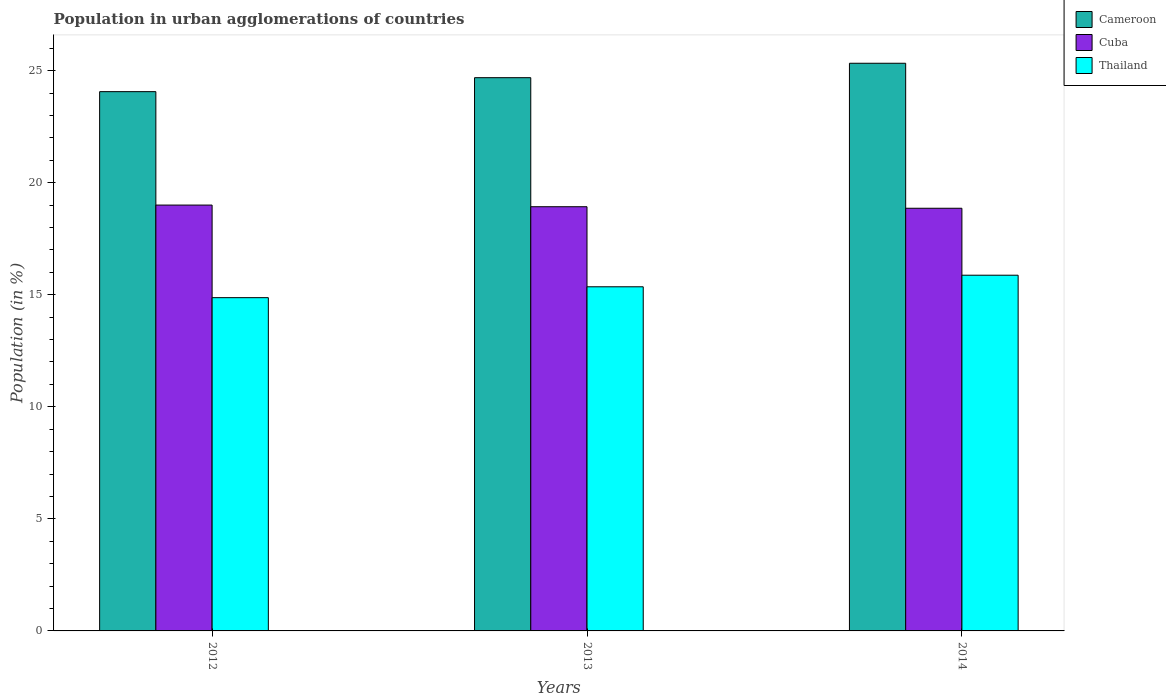How many different coloured bars are there?
Provide a succinct answer. 3. Are the number of bars per tick equal to the number of legend labels?
Keep it short and to the point. Yes. Are the number of bars on each tick of the X-axis equal?
Give a very brief answer. Yes. How many bars are there on the 3rd tick from the left?
Give a very brief answer. 3. How many bars are there on the 1st tick from the right?
Offer a very short reply. 3. In how many cases, is the number of bars for a given year not equal to the number of legend labels?
Your answer should be compact. 0. What is the percentage of population in urban agglomerations in Thailand in 2013?
Offer a very short reply. 15.36. Across all years, what is the maximum percentage of population in urban agglomerations in Thailand?
Keep it short and to the point. 15.87. Across all years, what is the minimum percentage of population in urban agglomerations in Cameroon?
Give a very brief answer. 24.06. In which year was the percentage of population in urban agglomerations in Thailand minimum?
Offer a terse response. 2012. What is the total percentage of population in urban agglomerations in Cameroon in the graph?
Your response must be concise. 74.08. What is the difference between the percentage of population in urban agglomerations in Cuba in 2013 and that in 2014?
Your answer should be compact. 0.07. What is the difference between the percentage of population in urban agglomerations in Cuba in 2012 and the percentage of population in urban agglomerations in Cameroon in 2013?
Offer a terse response. -5.68. What is the average percentage of population in urban agglomerations in Thailand per year?
Ensure brevity in your answer.  15.37. In the year 2012, what is the difference between the percentage of population in urban agglomerations in Cameroon and percentage of population in urban agglomerations in Thailand?
Make the answer very short. 9.19. In how many years, is the percentage of population in urban agglomerations in Cuba greater than 18 %?
Give a very brief answer. 3. What is the ratio of the percentage of population in urban agglomerations in Thailand in 2012 to that in 2014?
Keep it short and to the point. 0.94. Is the difference between the percentage of population in urban agglomerations in Cameroon in 2012 and 2014 greater than the difference between the percentage of population in urban agglomerations in Thailand in 2012 and 2014?
Offer a terse response. No. What is the difference between the highest and the second highest percentage of population in urban agglomerations in Thailand?
Offer a terse response. 0.52. What is the difference between the highest and the lowest percentage of population in urban agglomerations in Thailand?
Give a very brief answer. 1. What does the 2nd bar from the left in 2013 represents?
Your answer should be compact. Cuba. What does the 3rd bar from the right in 2012 represents?
Provide a short and direct response. Cameroon. Is it the case that in every year, the sum of the percentage of population in urban agglomerations in Thailand and percentage of population in urban agglomerations in Cuba is greater than the percentage of population in urban agglomerations in Cameroon?
Keep it short and to the point. Yes. How many bars are there?
Give a very brief answer. 9. How many years are there in the graph?
Offer a terse response. 3. What is the difference between two consecutive major ticks on the Y-axis?
Keep it short and to the point. 5. Are the values on the major ticks of Y-axis written in scientific E-notation?
Your response must be concise. No. Where does the legend appear in the graph?
Provide a short and direct response. Top right. What is the title of the graph?
Your response must be concise. Population in urban agglomerations of countries. Does "Gabon" appear as one of the legend labels in the graph?
Ensure brevity in your answer.  No. What is the label or title of the X-axis?
Your answer should be compact. Years. What is the Population (in %) of Cameroon in 2012?
Your answer should be very brief. 24.06. What is the Population (in %) in Cuba in 2012?
Your answer should be very brief. 19. What is the Population (in %) in Thailand in 2012?
Provide a succinct answer. 14.87. What is the Population (in %) of Cameroon in 2013?
Keep it short and to the point. 24.69. What is the Population (in %) of Cuba in 2013?
Make the answer very short. 18.93. What is the Population (in %) of Thailand in 2013?
Offer a very short reply. 15.36. What is the Population (in %) of Cameroon in 2014?
Offer a terse response. 25.33. What is the Population (in %) of Cuba in 2014?
Give a very brief answer. 18.86. What is the Population (in %) in Thailand in 2014?
Keep it short and to the point. 15.87. Across all years, what is the maximum Population (in %) of Cameroon?
Your answer should be very brief. 25.33. Across all years, what is the maximum Population (in %) in Cuba?
Ensure brevity in your answer.  19. Across all years, what is the maximum Population (in %) in Thailand?
Your answer should be very brief. 15.87. Across all years, what is the minimum Population (in %) of Cameroon?
Ensure brevity in your answer.  24.06. Across all years, what is the minimum Population (in %) of Cuba?
Your response must be concise. 18.86. Across all years, what is the minimum Population (in %) in Thailand?
Keep it short and to the point. 14.87. What is the total Population (in %) in Cameroon in the graph?
Offer a terse response. 74.08. What is the total Population (in %) in Cuba in the graph?
Offer a terse response. 56.79. What is the total Population (in %) of Thailand in the graph?
Make the answer very short. 46.1. What is the difference between the Population (in %) of Cameroon in 2012 and that in 2013?
Ensure brevity in your answer.  -0.62. What is the difference between the Population (in %) of Cuba in 2012 and that in 2013?
Offer a very short reply. 0.07. What is the difference between the Population (in %) in Thailand in 2012 and that in 2013?
Offer a terse response. -0.49. What is the difference between the Population (in %) of Cameroon in 2012 and that in 2014?
Your answer should be very brief. -1.27. What is the difference between the Population (in %) in Cuba in 2012 and that in 2014?
Your response must be concise. 0.14. What is the difference between the Population (in %) in Thailand in 2012 and that in 2014?
Your answer should be very brief. -1. What is the difference between the Population (in %) of Cameroon in 2013 and that in 2014?
Provide a short and direct response. -0.64. What is the difference between the Population (in %) in Cuba in 2013 and that in 2014?
Ensure brevity in your answer.  0.07. What is the difference between the Population (in %) in Thailand in 2013 and that in 2014?
Offer a very short reply. -0.52. What is the difference between the Population (in %) of Cameroon in 2012 and the Population (in %) of Cuba in 2013?
Provide a succinct answer. 5.14. What is the difference between the Population (in %) of Cameroon in 2012 and the Population (in %) of Thailand in 2013?
Keep it short and to the point. 8.71. What is the difference between the Population (in %) in Cuba in 2012 and the Population (in %) in Thailand in 2013?
Give a very brief answer. 3.65. What is the difference between the Population (in %) of Cameroon in 2012 and the Population (in %) of Cuba in 2014?
Give a very brief answer. 5.2. What is the difference between the Population (in %) of Cameroon in 2012 and the Population (in %) of Thailand in 2014?
Keep it short and to the point. 8.19. What is the difference between the Population (in %) of Cuba in 2012 and the Population (in %) of Thailand in 2014?
Give a very brief answer. 3.13. What is the difference between the Population (in %) in Cameroon in 2013 and the Population (in %) in Cuba in 2014?
Ensure brevity in your answer.  5.83. What is the difference between the Population (in %) of Cameroon in 2013 and the Population (in %) of Thailand in 2014?
Provide a short and direct response. 8.81. What is the difference between the Population (in %) in Cuba in 2013 and the Population (in %) in Thailand in 2014?
Make the answer very short. 3.06. What is the average Population (in %) in Cameroon per year?
Your answer should be very brief. 24.69. What is the average Population (in %) in Cuba per year?
Your response must be concise. 18.93. What is the average Population (in %) of Thailand per year?
Provide a short and direct response. 15.37. In the year 2012, what is the difference between the Population (in %) in Cameroon and Population (in %) in Cuba?
Offer a very short reply. 5.06. In the year 2012, what is the difference between the Population (in %) of Cameroon and Population (in %) of Thailand?
Ensure brevity in your answer.  9.19. In the year 2012, what is the difference between the Population (in %) of Cuba and Population (in %) of Thailand?
Give a very brief answer. 4.13. In the year 2013, what is the difference between the Population (in %) of Cameroon and Population (in %) of Cuba?
Keep it short and to the point. 5.76. In the year 2013, what is the difference between the Population (in %) in Cameroon and Population (in %) in Thailand?
Provide a succinct answer. 9.33. In the year 2013, what is the difference between the Population (in %) of Cuba and Population (in %) of Thailand?
Provide a succinct answer. 3.57. In the year 2014, what is the difference between the Population (in %) of Cameroon and Population (in %) of Cuba?
Your answer should be very brief. 6.47. In the year 2014, what is the difference between the Population (in %) of Cameroon and Population (in %) of Thailand?
Offer a terse response. 9.46. In the year 2014, what is the difference between the Population (in %) of Cuba and Population (in %) of Thailand?
Give a very brief answer. 2.99. What is the ratio of the Population (in %) of Cameroon in 2012 to that in 2013?
Give a very brief answer. 0.97. What is the ratio of the Population (in %) of Thailand in 2012 to that in 2013?
Offer a very short reply. 0.97. What is the ratio of the Population (in %) in Cuba in 2012 to that in 2014?
Keep it short and to the point. 1.01. What is the ratio of the Population (in %) in Thailand in 2012 to that in 2014?
Keep it short and to the point. 0.94. What is the ratio of the Population (in %) of Cameroon in 2013 to that in 2014?
Keep it short and to the point. 0.97. What is the ratio of the Population (in %) of Cuba in 2013 to that in 2014?
Ensure brevity in your answer.  1. What is the ratio of the Population (in %) in Thailand in 2013 to that in 2014?
Ensure brevity in your answer.  0.97. What is the difference between the highest and the second highest Population (in %) of Cameroon?
Provide a succinct answer. 0.64. What is the difference between the highest and the second highest Population (in %) of Cuba?
Ensure brevity in your answer.  0.07. What is the difference between the highest and the second highest Population (in %) in Thailand?
Provide a short and direct response. 0.52. What is the difference between the highest and the lowest Population (in %) in Cameroon?
Keep it short and to the point. 1.27. What is the difference between the highest and the lowest Population (in %) in Cuba?
Provide a short and direct response. 0.14. 